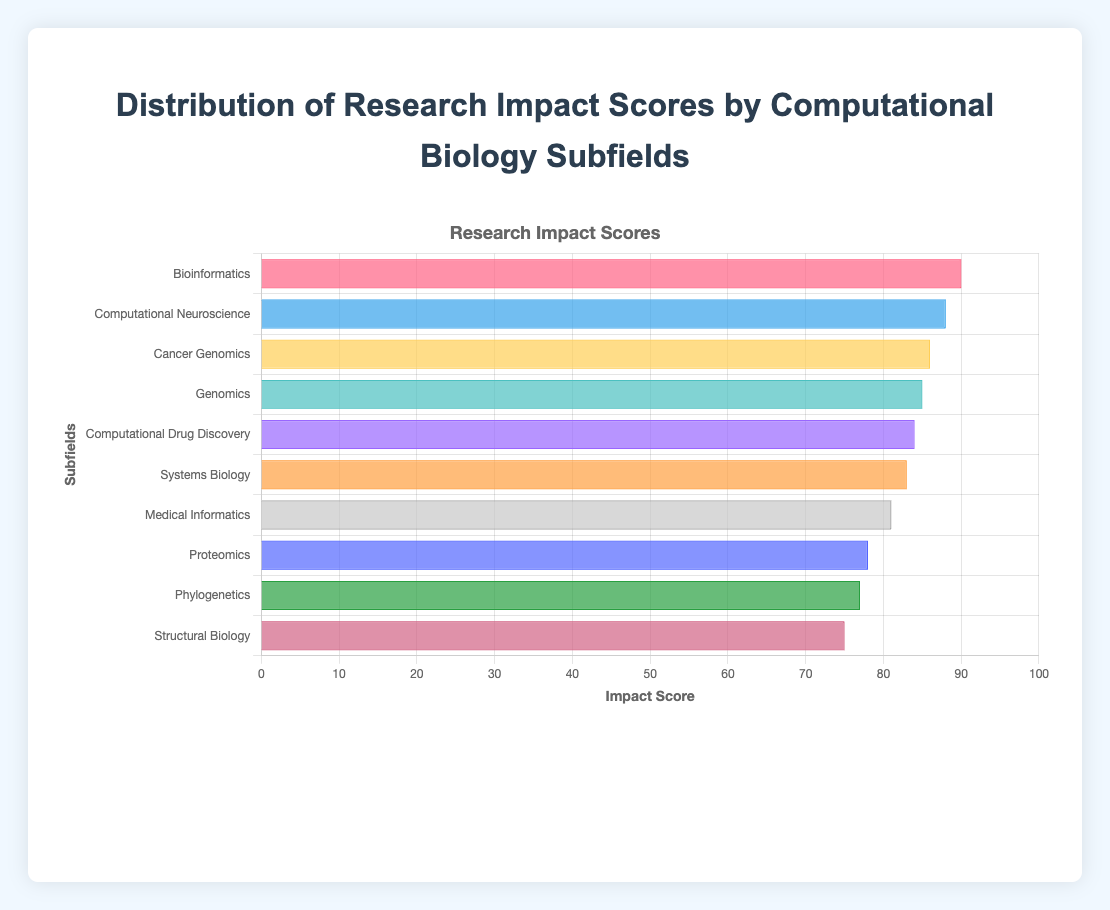What is the subfield with the highest research impact score? The subfield with the highest impact score is identified by the tallest bar on the horizontal bar chart. The label corresponding to the tallest bar is Bioinformatics.
Answer: Bioinformatics Which subfield has a lower impact score, Proteomics or Medical Informatics? By comparing the lengths of the bars for Proteomics and Medical Informatics, it is apparent that the bar for Proteomics is shorter than the bar for Medical Informatics.
Answer: Proteomics What is the average impact score of Systems Biology and Computational Drug Discovery? Systems Biology has an impact score of 83, and Computational Drug Discovery has an impact score of 84. The average is calculated as (83 + 84) / 2.
Answer: 83.5 What is the difference between the impact scores of Cancer Genomics and Structural Biology? Cancer Genomics has an impact score of 86, and Structural Biology has an impact score of 75. The difference is 86 - 75.
Answer: 11 What is the sum of the impact scores of Genomics, Proteomics, and Phylogenetics? The impact scores are: Genomics (85), Proteomics (78), and Phylogenetics (77). The sum is 85 + 78 + 77.
Answer: 240 How many subfields have an impact score greater than 80? By counting the number of bars longer than the point marked 80 on the x-axis, we find Bioinformatics, Computational Neuroscience, Cancer Genomics, Genomics, Computational Drug Discovery, Systems Biology, and Medical Informatics.
Answer: 7 Between which subfield and another does the impact score differ by exactly 3? By inspecting the chart, we compare the bars and find that Genomics (85) and Systems Biology (83) have a difference of 2, but no two subfields have exactly a difference of 3.
Answer: None Which subfield is represented by the green-colored bar? The green-colored bar corresponds to Phylogenetics.
Answer: Phylogenetics What is the median impact score of the subfields? First, list the impact scores in ascending order: [75, 77, 78, 81, 83, 84, 85, 86, 88, 90]. The median is the middle value of the sorted list, which is (83 + 84) / 2.
Answer: 83.5 What is the funding for the subfield with the second-highest research impact score? The second-highest research impact score is 88 (after 90 for Bioinformatics), which corresponds to Computational Neuroscience. The funding for Computational Neuroscience is $2,200,000.
Answer: $2,200,000 